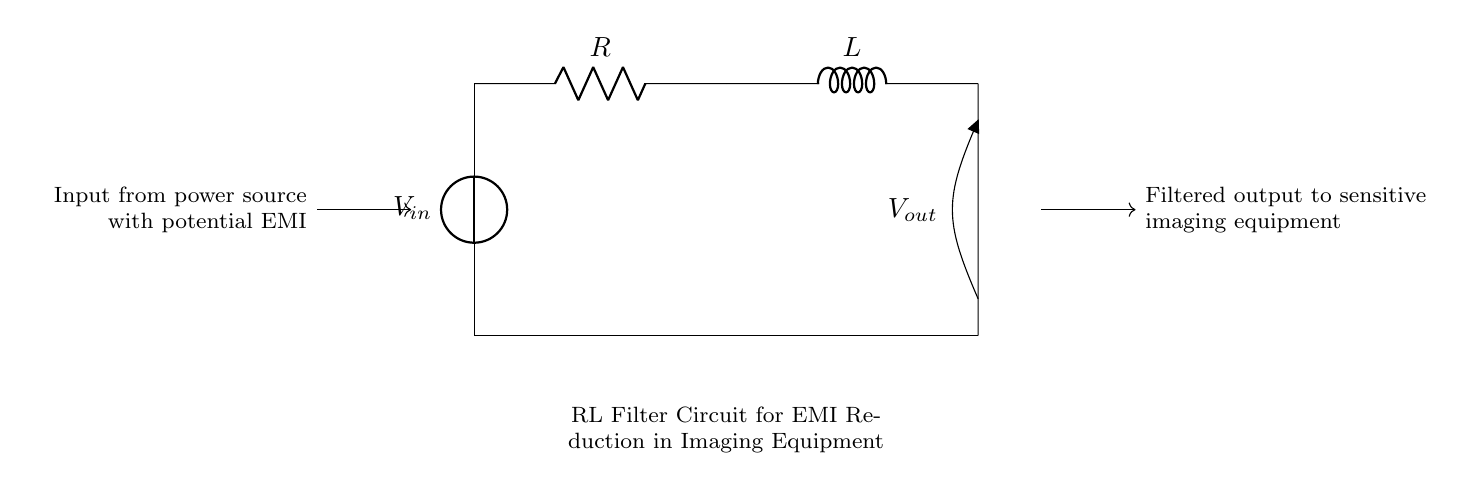What type of circuit is represented? The circuit is an RL filter circuit, which consists of a resistor and an inductor. The presence of these two components suggests its purpose of filtering out unwanted signals.
Answer: RL filter circuit What do R and L represent? R represents resistance in ohms, while L represents inductance in henries. These components are key to managing the circuit's response to electromagnetic interference.
Answer: Resistance and inductance What is the role of the inductor in this circuit? The inductor is primarily used to oppose changes in current and filter out high-frequency noise, which is crucial for reducing electromagnetic interference for sensitive equipment.
Answer: Filter high-frequency noise What happens at the output terminal of the circuit? The output terminal provides a filtered voltage that has been reduced of unwanted electromagnetic interference before it reaches the sensitive imaging equipment.
Answer: Filtered output voltage How would you describe the input signal characteristics? The input signal presumably contains unwanted electromagnetic interference, which emphasizes the need for filtering. This is indicated by the labeling of the input from the power source.
Answer: Contains EMI What effect does increasing the resistance have on the filtering capability? Increasing the resistance would lower the overall current in the circuit, potentially making it more effective at filtering out noise, but may also slow the response time of the circuit.
Answer: Lower current, better filtering What is the benefit of using this RL filter circuit over a simple resistor-only circuit? The RL filter circuit offers better frequency response and reduced noise levels compared to a resistor-only circuit since the inductor can handle and suppress fluctuations more effectively.
Answer: Better noise suppression 